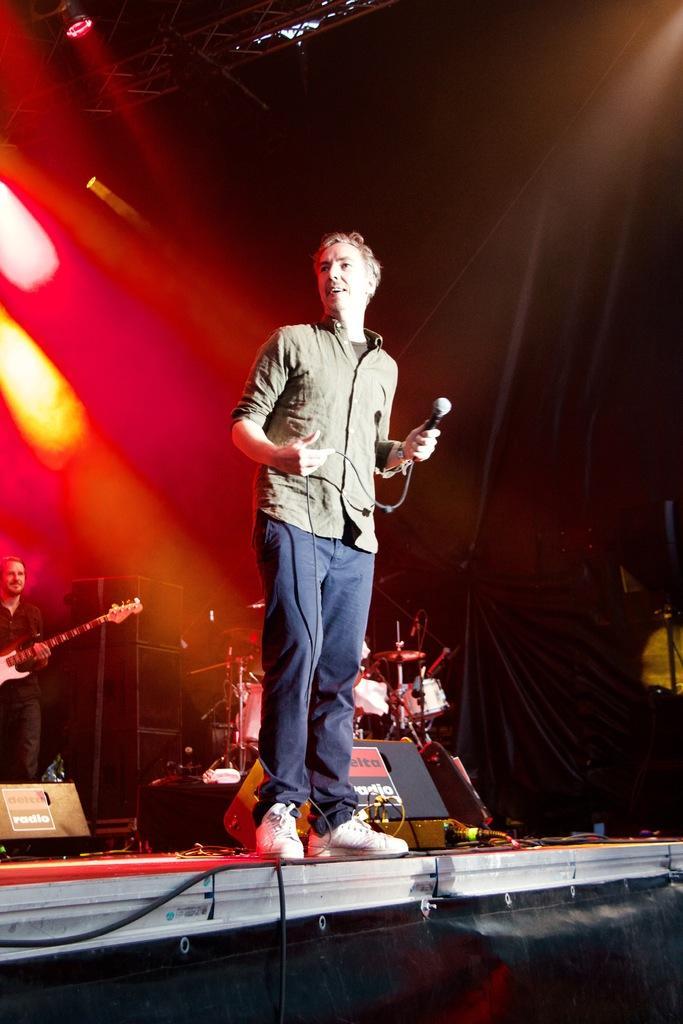Describe this image in one or two sentences. In this image I can see a person holding the mic. At the back of him there is a person holding the guitar. 